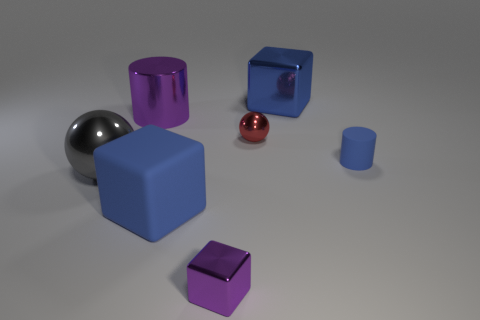Subtract all yellow spheres. Subtract all cyan blocks. How many spheres are left? 2 Add 1 large blue rubber objects. How many objects exist? 8 Subtract all blocks. How many objects are left? 4 Add 2 purple cubes. How many purple cubes exist? 3 Subtract 1 blue cubes. How many objects are left? 6 Subtract all small red spheres. Subtract all blue cylinders. How many objects are left? 5 Add 1 metallic spheres. How many metallic spheres are left? 3 